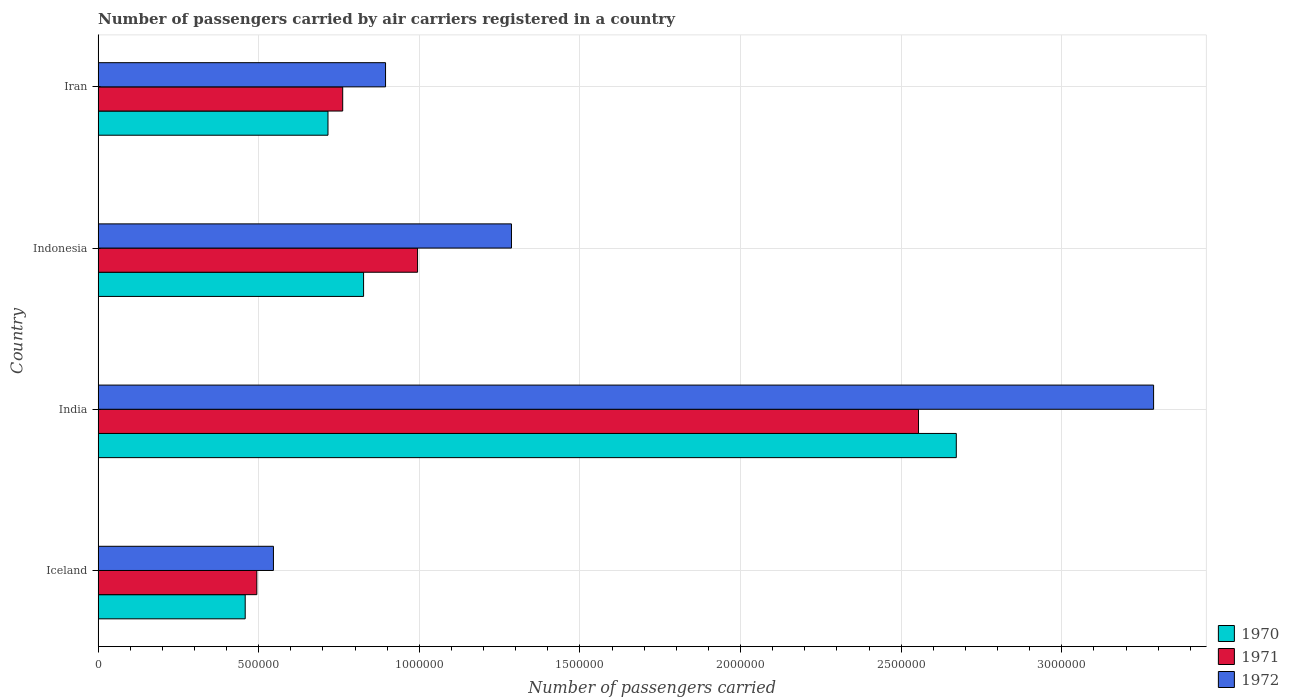How many different coloured bars are there?
Provide a succinct answer. 3. How many bars are there on the 4th tick from the bottom?
Offer a terse response. 3. What is the label of the 1st group of bars from the top?
Your answer should be very brief. Iran. What is the number of passengers carried by air carriers in 1971 in Iran?
Your answer should be compact. 7.61e+05. Across all countries, what is the maximum number of passengers carried by air carriers in 1972?
Your response must be concise. 3.29e+06. Across all countries, what is the minimum number of passengers carried by air carriers in 1972?
Your answer should be very brief. 5.46e+05. In which country was the number of passengers carried by air carriers in 1972 minimum?
Keep it short and to the point. Iceland. What is the total number of passengers carried by air carriers in 1970 in the graph?
Offer a terse response. 4.67e+06. What is the difference between the number of passengers carried by air carriers in 1971 in India and that in Indonesia?
Your answer should be compact. 1.56e+06. What is the difference between the number of passengers carried by air carriers in 1971 in Indonesia and the number of passengers carried by air carriers in 1972 in Iran?
Your answer should be very brief. 9.97e+04. What is the average number of passengers carried by air carriers in 1970 per country?
Provide a short and direct response. 1.17e+06. What is the difference between the number of passengers carried by air carriers in 1971 and number of passengers carried by air carriers in 1970 in Iran?
Offer a very short reply. 4.58e+04. In how many countries, is the number of passengers carried by air carriers in 1970 greater than 2100000 ?
Provide a succinct answer. 1. What is the ratio of the number of passengers carried by air carriers in 1971 in Iceland to that in India?
Keep it short and to the point. 0.19. What is the difference between the highest and the second highest number of passengers carried by air carriers in 1972?
Your answer should be very brief. 2.00e+06. What is the difference between the highest and the lowest number of passengers carried by air carriers in 1970?
Offer a very short reply. 2.21e+06. Is the sum of the number of passengers carried by air carriers in 1970 in Iceland and India greater than the maximum number of passengers carried by air carriers in 1971 across all countries?
Your response must be concise. Yes. What is the difference between two consecutive major ticks on the X-axis?
Ensure brevity in your answer.  5.00e+05. Are the values on the major ticks of X-axis written in scientific E-notation?
Provide a succinct answer. No. Does the graph contain any zero values?
Your response must be concise. No. Where does the legend appear in the graph?
Make the answer very short. Bottom right. How many legend labels are there?
Give a very brief answer. 3. How are the legend labels stacked?
Your answer should be very brief. Vertical. What is the title of the graph?
Your answer should be very brief. Number of passengers carried by air carriers registered in a country. What is the label or title of the X-axis?
Your response must be concise. Number of passengers carried. What is the label or title of the Y-axis?
Make the answer very short. Country. What is the Number of passengers carried of 1970 in Iceland?
Provide a short and direct response. 4.58e+05. What is the Number of passengers carried in 1971 in Iceland?
Your answer should be very brief. 4.94e+05. What is the Number of passengers carried in 1972 in Iceland?
Ensure brevity in your answer.  5.46e+05. What is the Number of passengers carried in 1970 in India?
Offer a terse response. 2.67e+06. What is the Number of passengers carried in 1971 in India?
Provide a succinct answer. 2.55e+06. What is the Number of passengers carried in 1972 in India?
Your answer should be compact. 3.29e+06. What is the Number of passengers carried in 1970 in Indonesia?
Ensure brevity in your answer.  8.26e+05. What is the Number of passengers carried in 1971 in Indonesia?
Offer a terse response. 9.94e+05. What is the Number of passengers carried of 1972 in Indonesia?
Offer a terse response. 1.29e+06. What is the Number of passengers carried of 1970 in Iran?
Make the answer very short. 7.16e+05. What is the Number of passengers carried in 1971 in Iran?
Offer a very short reply. 7.61e+05. What is the Number of passengers carried of 1972 in Iran?
Offer a very short reply. 8.95e+05. Across all countries, what is the maximum Number of passengers carried of 1970?
Offer a terse response. 2.67e+06. Across all countries, what is the maximum Number of passengers carried in 1971?
Your answer should be compact. 2.55e+06. Across all countries, what is the maximum Number of passengers carried in 1972?
Make the answer very short. 3.29e+06. Across all countries, what is the minimum Number of passengers carried of 1970?
Ensure brevity in your answer.  4.58e+05. Across all countries, what is the minimum Number of passengers carried of 1971?
Your response must be concise. 4.94e+05. Across all countries, what is the minimum Number of passengers carried in 1972?
Your answer should be compact. 5.46e+05. What is the total Number of passengers carried in 1970 in the graph?
Make the answer very short. 4.67e+06. What is the total Number of passengers carried of 1971 in the graph?
Make the answer very short. 4.80e+06. What is the total Number of passengers carried of 1972 in the graph?
Provide a succinct answer. 6.01e+06. What is the difference between the Number of passengers carried in 1970 in Iceland and that in India?
Offer a terse response. -2.21e+06. What is the difference between the Number of passengers carried of 1971 in Iceland and that in India?
Your answer should be very brief. -2.06e+06. What is the difference between the Number of passengers carried of 1972 in Iceland and that in India?
Your answer should be compact. -2.74e+06. What is the difference between the Number of passengers carried in 1970 in Iceland and that in Indonesia?
Offer a terse response. -3.68e+05. What is the difference between the Number of passengers carried in 1971 in Iceland and that in Indonesia?
Give a very brief answer. -5.00e+05. What is the difference between the Number of passengers carried of 1972 in Iceland and that in Indonesia?
Make the answer very short. -7.41e+05. What is the difference between the Number of passengers carried in 1970 in Iceland and that in Iran?
Keep it short and to the point. -2.58e+05. What is the difference between the Number of passengers carried of 1971 in Iceland and that in Iran?
Offer a very short reply. -2.67e+05. What is the difference between the Number of passengers carried of 1972 in Iceland and that in Iran?
Keep it short and to the point. -3.49e+05. What is the difference between the Number of passengers carried in 1970 in India and that in Indonesia?
Ensure brevity in your answer.  1.85e+06. What is the difference between the Number of passengers carried in 1971 in India and that in Indonesia?
Provide a succinct answer. 1.56e+06. What is the difference between the Number of passengers carried in 1972 in India and that in Indonesia?
Give a very brief answer. 2.00e+06. What is the difference between the Number of passengers carried of 1970 in India and that in Iran?
Offer a terse response. 1.96e+06. What is the difference between the Number of passengers carried of 1971 in India and that in Iran?
Make the answer very short. 1.79e+06. What is the difference between the Number of passengers carried in 1972 in India and that in Iran?
Make the answer very short. 2.39e+06. What is the difference between the Number of passengers carried of 1970 in Indonesia and that in Iran?
Offer a very short reply. 1.11e+05. What is the difference between the Number of passengers carried in 1971 in Indonesia and that in Iran?
Your answer should be compact. 2.33e+05. What is the difference between the Number of passengers carried of 1972 in Indonesia and that in Iran?
Your response must be concise. 3.92e+05. What is the difference between the Number of passengers carried in 1970 in Iceland and the Number of passengers carried in 1971 in India?
Give a very brief answer. -2.10e+06. What is the difference between the Number of passengers carried of 1970 in Iceland and the Number of passengers carried of 1972 in India?
Your answer should be compact. -2.83e+06. What is the difference between the Number of passengers carried in 1971 in Iceland and the Number of passengers carried in 1972 in India?
Make the answer very short. -2.79e+06. What is the difference between the Number of passengers carried of 1970 in Iceland and the Number of passengers carried of 1971 in Indonesia?
Give a very brief answer. -5.37e+05. What is the difference between the Number of passengers carried in 1970 in Iceland and the Number of passengers carried in 1972 in Indonesia?
Keep it short and to the point. -8.29e+05. What is the difference between the Number of passengers carried in 1971 in Iceland and the Number of passengers carried in 1972 in Indonesia?
Offer a very short reply. -7.93e+05. What is the difference between the Number of passengers carried in 1970 in Iceland and the Number of passengers carried in 1971 in Iran?
Keep it short and to the point. -3.04e+05. What is the difference between the Number of passengers carried in 1970 in Iceland and the Number of passengers carried in 1972 in Iran?
Your response must be concise. -4.37e+05. What is the difference between the Number of passengers carried in 1971 in Iceland and the Number of passengers carried in 1972 in Iran?
Provide a succinct answer. -4.01e+05. What is the difference between the Number of passengers carried in 1970 in India and the Number of passengers carried in 1971 in Indonesia?
Keep it short and to the point. 1.68e+06. What is the difference between the Number of passengers carried of 1970 in India and the Number of passengers carried of 1972 in Indonesia?
Offer a very short reply. 1.38e+06. What is the difference between the Number of passengers carried in 1971 in India and the Number of passengers carried in 1972 in Indonesia?
Your answer should be compact. 1.27e+06. What is the difference between the Number of passengers carried in 1970 in India and the Number of passengers carried in 1971 in Iran?
Your answer should be very brief. 1.91e+06. What is the difference between the Number of passengers carried in 1970 in India and the Number of passengers carried in 1972 in Iran?
Provide a short and direct response. 1.78e+06. What is the difference between the Number of passengers carried in 1971 in India and the Number of passengers carried in 1972 in Iran?
Your response must be concise. 1.66e+06. What is the difference between the Number of passengers carried in 1970 in Indonesia and the Number of passengers carried in 1971 in Iran?
Provide a short and direct response. 6.50e+04. What is the difference between the Number of passengers carried in 1970 in Indonesia and the Number of passengers carried in 1972 in Iran?
Keep it short and to the point. -6.84e+04. What is the difference between the Number of passengers carried of 1971 in Indonesia and the Number of passengers carried of 1972 in Iran?
Your response must be concise. 9.97e+04. What is the average Number of passengers carried of 1970 per country?
Offer a terse response. 1.17e+06. What is the average Number of passengers carried in 1971 per country?
Your answer should be very brief. 1.20e+06. What is the average Number of passengers carried in 1972 per country?
Your answer should be compact. 1.50e+06. What is the difference between the Number of passengers carried in 1970 and Number of passengers carried in 1971 in Iceland?
Offer a very short reply. -3.62e+04. What is the difference between the Number of passengers carried in 1970 and Number of passengers carried in 1972 in Iceland?
Provide a short and direct response. -8.79e+04. What is the difference between the Number of passengers carried of 1971 and Number of passengers carried of 1972 in Iceland?
Offer a very short reply. -5.17e+04. What is the difference between the Number of passengers carried of 1970 and Number of passengers carried of 1971 in India?
Keep it short and to the point. 1.18e+05. What is the difference between the Number of passengers carried of 1970 and Number of passengers carried of 1972 in India?
Provide a succinct answer. -6.14e+05. What is the difference between the Number of passengers carried in 1971 and Number of passengers carried in 1972 in India?
Your answer should be very brief. -7.32e+05. What is the difference between the Number of passengers carried in 1970 and Number of passengers carried in 1971 in Indonesia?
Ensure brevity in your answer.  -1.68e+05. What is the difference between the Number of passengers carried in 1970 and Number of passengers carried in 1972 in Indonesia?
Ensure brevity in your answer.  -4.60e+05. What is the difference between the Number of passengers carried of 1971 and Number of passengers carried of 1972 in Indonesia?
Your answer should be very brief. -2.92e+05. What is the difference between the Number of passengers carried of 1970 and Number of passengers carried of 1971 in Iran?
Offer a terse response. -4.58e+04. What is the difference between the Number of passengers carried of 1970 and Number of passengers carried of 1972 in Iran?
Provide a succinct answer. -1.79e+05. What is the difference between the Number of passengers carried in 1971 and Number of passengers carried in 1972 in Iran?
Your answer should be very brief. -1.33e+05. What is the ratio of the Number of passengers carried in 1970 in Iceland to that in India?
Provide a succinct answer. 0.17. What is the ratio of the Number of passengers carried in 1971 in Iceland to that in India?
Provide a succinct answer. 0.19. What is the ratio of the Number of passengers carried of 1972 in Iceland to that in India?
Your answer should be very brief. 0.17. What is the ratio of the Number of passengers carried of 1970 in Iceland to that in Indonesia?
Your answer should be compact. 0.55. What is the ratio of the Number of passengers carried in 1971 in Iceland to that in Indonesia?
Ensure brevity in your answer.  0.5. What is the ratio of the Number of passengers carried in 1972 in Iceland to that in Indonesia?
Make the answer very short. 0.42. What is the ratio of the Number of passengers carried in 1970 in Iceland to that in Iran?
Your answer should be compact. 0.64. What is the ratio of the Number of passengers carried of 1971 in Iceland to that in Iran?
Your answer should be compact. 0.65. What is the ratio of the Number of passengers carried in 1972 in Iceland to that in Iran?
Your answer should be very brief. 0.61. What is the ratio of the Number of passengers carried in 1970 in India to that in Indonesia?
Provide a short and direct response. 3.23. What is the ratio of the Number of passengers carried in 1971 in India to that in Indonesia?
Provide a succinct answer. 2.57. What is the ratio of the Number of passengers carried in 1972 in India to that in Indonesia?
Provide a succinct answer. 2.55. What is the ratio of the Number of passengers carried in 1970 in India to that in Iran?
Provide a succinct answer. 3.73. What is the ratio of the Number of passengers carried in 1971 in India to that in Iran?
Offer a very short reply. 3.35. What is the ratio of the Number of passengers carried of 1972 in India to that in Iran?
Keep it short and to the point. 3.67. What is the ratio of the Number of passengers carried in 1970 in Indonesia to that in Iran?
Your answer should be compact. 1.15. What is the ratio of the Number of passengers carried in 1971 in Indonesia to that in Iran?
Offer a very short reply. 1.31. What is the ratio of the Number of passengers carried of 1972 in Indonesia to that in Iran?
Your response must be concise. 1.44. What is the difference between the highest and the second highest Number of passengers carried in 1970?
Offer a terse response. 1.85e+06. What is the difference between the highest and the second highest Number of passengers carried in 1971?
Make the answer very short. 1.56e+06. What is the difference between the highest and the second highest Number of passengers carried in 1972?
Keep it short and to the point. 2.00e+06. What is the difference between the highest and the lowest Number of passengers carried in 1970?
Offer a very short reply. 2.21e+06. What is the difference between the highest and the lowest Number of passengers carried in 1971?
Provide a succinct answer. 2.06e+06. What is the difference between the highest and the lowest Number of passengers carried of 1972?
Offer a terse response. 2.74e+06. 